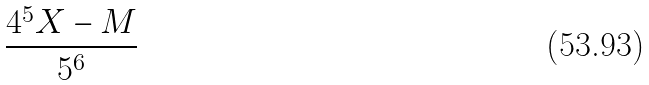Convert formula to latex. <formula><loc_0><loc_0><loc_500><loc_500>\frac { 4 ^ { 5 } X - M } { 5 ^ { 6 } }</formula> 